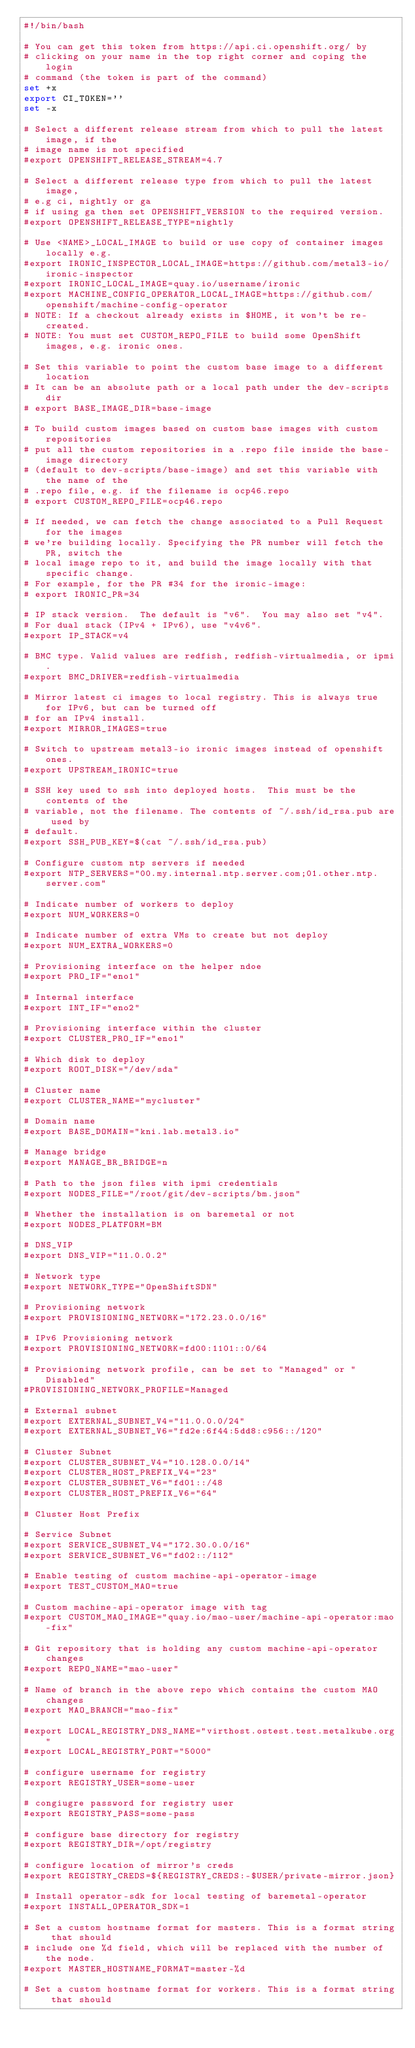<code> <loc_0><loc_0><loc_500><loc_500><_Bash_>#!/bin/bash

# You can get this token from https://api.ci.openshift.org/ by
# clicking on your name in the top right corner and coping the login
# command (the token is part of the command)
set +x
export CI_TOKEN=''
set -x

# Select a different release stream from which to pull the latest image, if the
# image name is not specified
#export OPENSHIFT_RELEASE_STREAM=4.7

# Select a different release type from which to pull the latest image,
# e.g ci, nightly or ga
# if using ga then set OPENSHIFT_VERSION to the required version.
#export OPENSHIFT_RELEASE_TYPE=nightly

# Use <NAME>_LOCAL_IMAGE to build or use copy of container images locally e.g.
#export IRONIC_INSPECTOR_LOCAL_IMAGE=https://github.com/metal3-io/ironic-inspector
#export IRONIC_LOCAL_IMAGE=quay.io/username/ironic
#export MACHINE_CONFIG_OPERATOR_LOCAL_IMAGE=https://github.com/openshift/machine-config-operator
# NOTE: If a checkout already exists in $HOME, it won't be re-created.
# NOTE: You must set CUSTOM_REPO_FILE to build some OpenShift images, e.g. ironic ones.

# Set this variable to point the custom base image to a different location
# It can be an absolute path or a local path under the dev-scripts dir
# export BASE_IMAGE_DIR=base-image

# To build custom images based on custom base images with custom repositories
# put all the custom repositories in a .repo file inside the base-image directory
# (default to dev-scripts/base-image) and set this variable with the name of the
# .repo file, e.g. if the filename is ocp46.repo
# export CUSTOM_REPO_FILE=ocp46.repo

# If needed, we can fetch the change associated to a Pull Request for the images
# we're building locally. Specifying the PR number will fetch the PR, switch the
# local image repo to it, and build the image locally with that specific change.
# For example, for the PR #34 for the ironic-image:
# export IRONIC_PR=34

# IP stack version.  The default is "v6".  You may also set "v4".
# For dual stack (IPv4 + IPv6), use "v4v6".
#export IP_STACK=v4

# BMC type. Valid values are redfish, redfish-virtualmedia, or ipmi.
#export BMC_DRIVER=redfish-virtualmedia

# Mirror latest ci images to local registry. This is always true for IPv6, but can be turned off
# for an IPv4 install.
#export MIRROR_IMAGES=true

# Switch to upstream metal3-io ironic images instead of openshift ones.
#export UPSTREAM_IRONIC=true

# SSH key used to ssh into deployed hosts.  This must be the contents of the
# variable, not the filename. The contents of ~/.ssh/id_rsa.pub are used by
# default.
#export SSH_PUB_KEY=$(cat ~/.ssh/id_rsa.pub)

# Configure custom ntp servers if needed
#export NTP_SERVERS="00.my.internal.ntp.server.com;01.other.ntp.server.com"

# Indicate number of workers to deploy
#export NUM_WORKERS=0

# Indicate number of extra VMs to create but not deploy
#export NUM_EXTRA_WORKERS=0

# Provisioning interface on the helper ndoe
#export PRO_IF="eno1"

# Internal interface
#export INT_IF="eno2"

# Provisioning interface within the cluster
#export CLUSTER_PRO_IF="eno1"

# Which disk to deploy
#export ROOT_DISK="/dev/sda"

# Cluster name
#export CLUSTER_NAME="mycluster"

# Domain name
#export BASE_DOMAIN="kni.lab.metal3.io"

# Manage bridge
#export MANAGE_BR_BRIDGE=n

# Path to the json files with ipmi credentials
#export NODES_FILE="/root/git/dev-scripts/bm.json"

# Whether the installation is on baremetal or not
#export NODES_PLATFORM=BM

# DNS_VIP
#export DNS_VIP="11.0.0.2"

# Network type
#export NETWORK_TYPE="OpenShiftSDN"

# Provisioning network
#export PROVISIONING_NETWORK="172.23.0.0/16"

# IPv6 Provisioning network
#export PROVISIONING_NETWORK=fd00:1101::0/64

# Provisioning network profile, can be set to "Managed" or "Disabled"
#PROVISIONING_NETWORK_PROFILE=Managed

# External subnet
#export EXTERNAL_SUBNET_V4="11.0.0.0/24"
#export EXTERNAL_SUBNET_V6="fd2e:6f44:5dd8:c956::/120"

# Cluster Subnet
#export CLUSTER_SUBNET_V4="10.128.0.0/14"
#export CLUSTER_HOST_PREFIX_V4="23"
#export CLUSTER_SUBNET_V6="fd01::/48
#export CLUSTER_HOST_PREFIX_V6="64"

# Cluster Host Prefix

# Service Subnet
#export SERVICE_SUBNET_V4="172.30.0.0/16"
#export SERVICE_SUBNET_V6="fd02::/112"

# Enable testing of custom machine-api-operator-image
#export TEST_CUSTOM_MAO=true

# Custom machine-api-operator image with tag
#export CUSTOM_MAO_IMAGE="quay.io/mao-user/machine-api-operator:mao-fix"

# Git repository that is holding any custom machine-api-operator changes
#export REPO_NAME="mao-user"

# Name of branch in the above repo which contains the custom MAO changes
#export MAO_BRANCH="mao-fix"

#export LOCAL_REGISTRY_DNS_NAME="virthost.ostest.test.metalkube.org"
#export LOCAL_REGISTRY_PORT="5000"

# configure username for registry
#export REGISTRY_USER=some-user

# congiugre password for registry user
#export REGISTRY_PASS=some-pass

# configure base directory for registry
#export REGISTRY_DIR=/opt/registry

# configure location of mirror's creds
#export REGISTRY_CREDS=${REGISTRY_CREDS:-$USER/private-mirror.json}

# Install operator-sdk for local testing of baremetal-operator
#export INSTALL_OPERATOR_SDK=1

# Set a custom hostname format for masters. This is a format string that should
# include one %d field, which will be replaced with the number of the node.
#export MASTER_HOSTNAME_FORMAT=master-%d

# Set a custom hostname format for workers. This is a format string that should</code> 